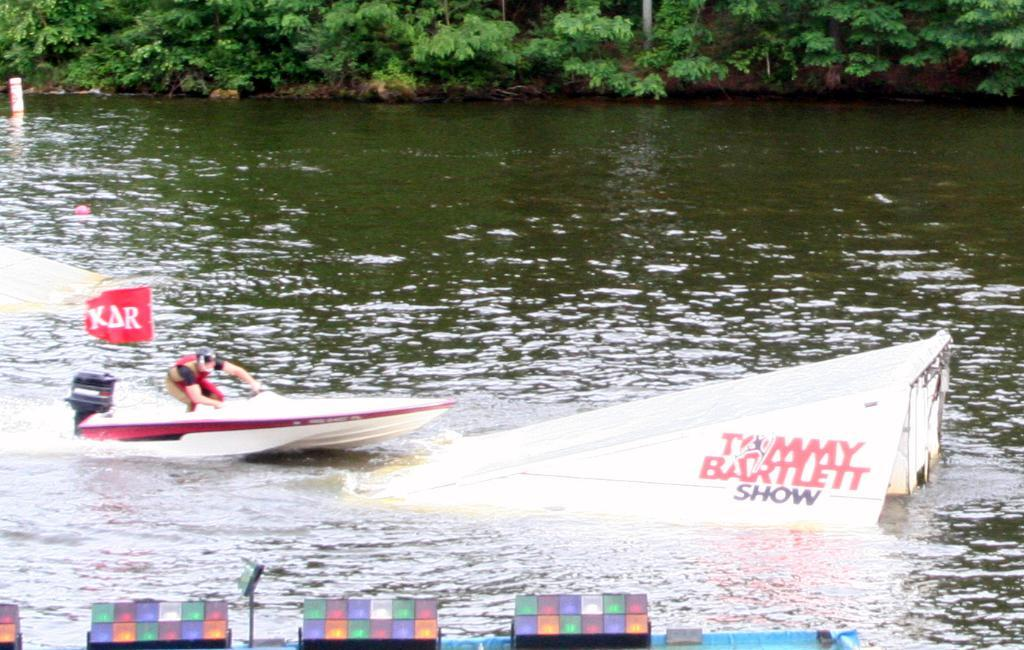What is the person in the image doing? The person is in a boat in the image. What is the boat floating on? The boat is floating on water. How does the water appear in the image? The water's surface appears curved. What else can be seen in the image besides the boat and person? There are lights and trees visible in the image. What type of support can be seen holding up the town in the image? There is no town present in the image, so there is no support holding up a town. 